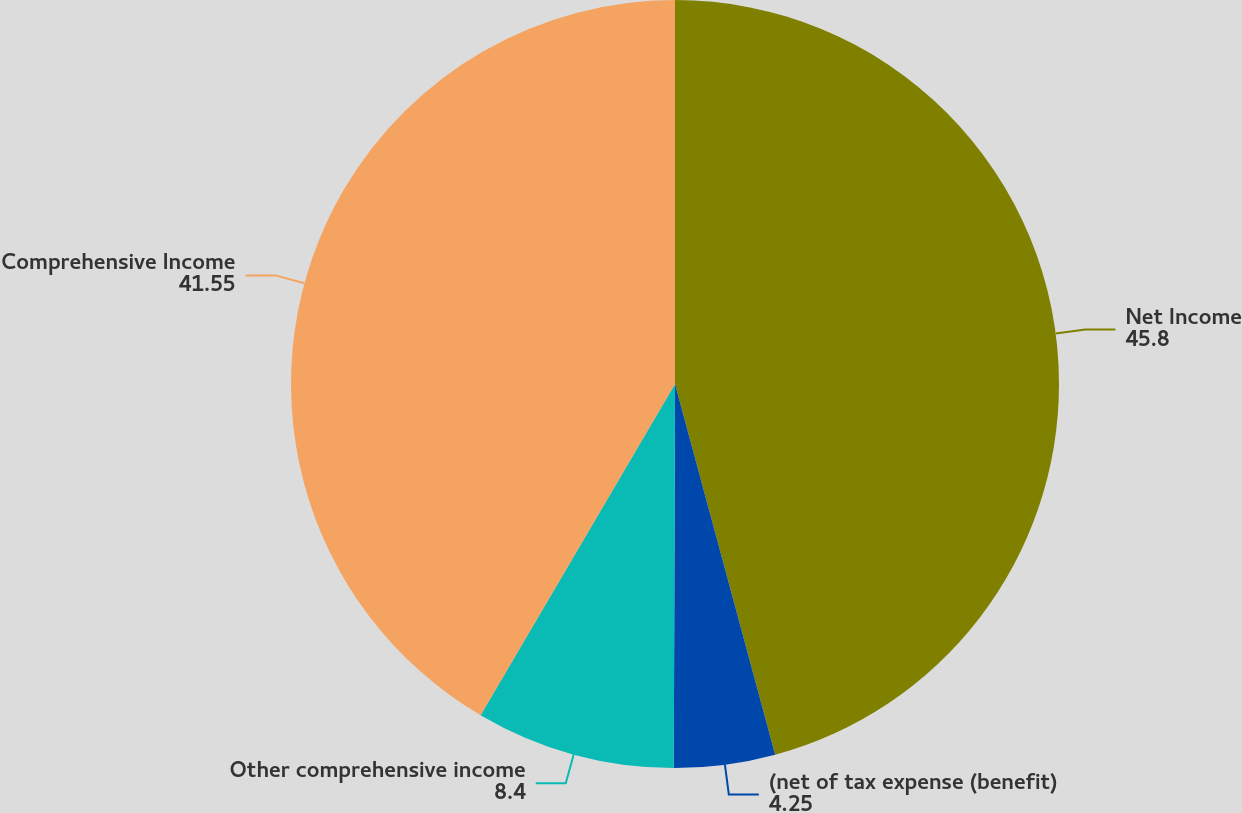Convert chart. <chart><loc_0><loc_0><loc_500><loc_500><pie_chart><fcel>Net Income<fcel>(net of tax expense (benefit)<fcel>Other comprehensive income<fcel>Comprehensive Income<nl><fcel>45.8%<fcel>4.25%<fcel>8.4%<fcel>41.55%<nl></chart> 